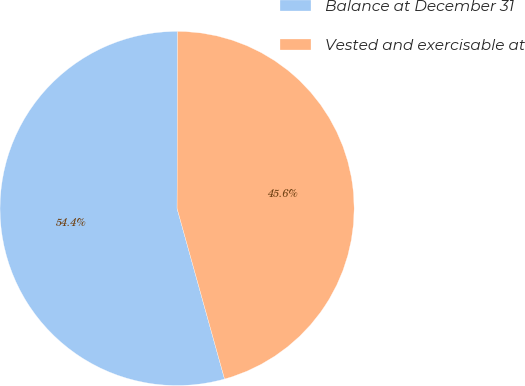Convert chart. <chart><loc_0><loc_0><loc_500><loc_500><pie_chart><fcel>Balance at December 31<fcel>Vested and exercisable at<nl><fcel>54.37%<fcel>45.63%<nl></chart> 